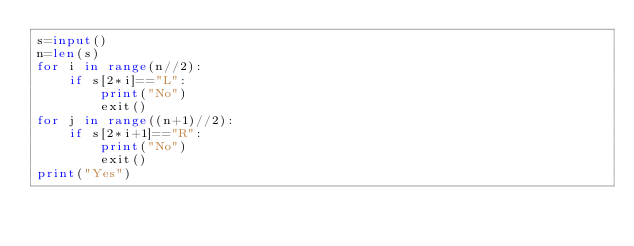<code> <loc_0><loc_0><loc_500><loc_500><_Python_>s=input()
n=len(s)
for i in range(n//2):
    if s[2*i]=="L":
        print("No")
        exit()
for j in range((n+1)//2):
    if s[2*i+1]=="R":
        print("No")
        exit()
print("Yes")</code> 